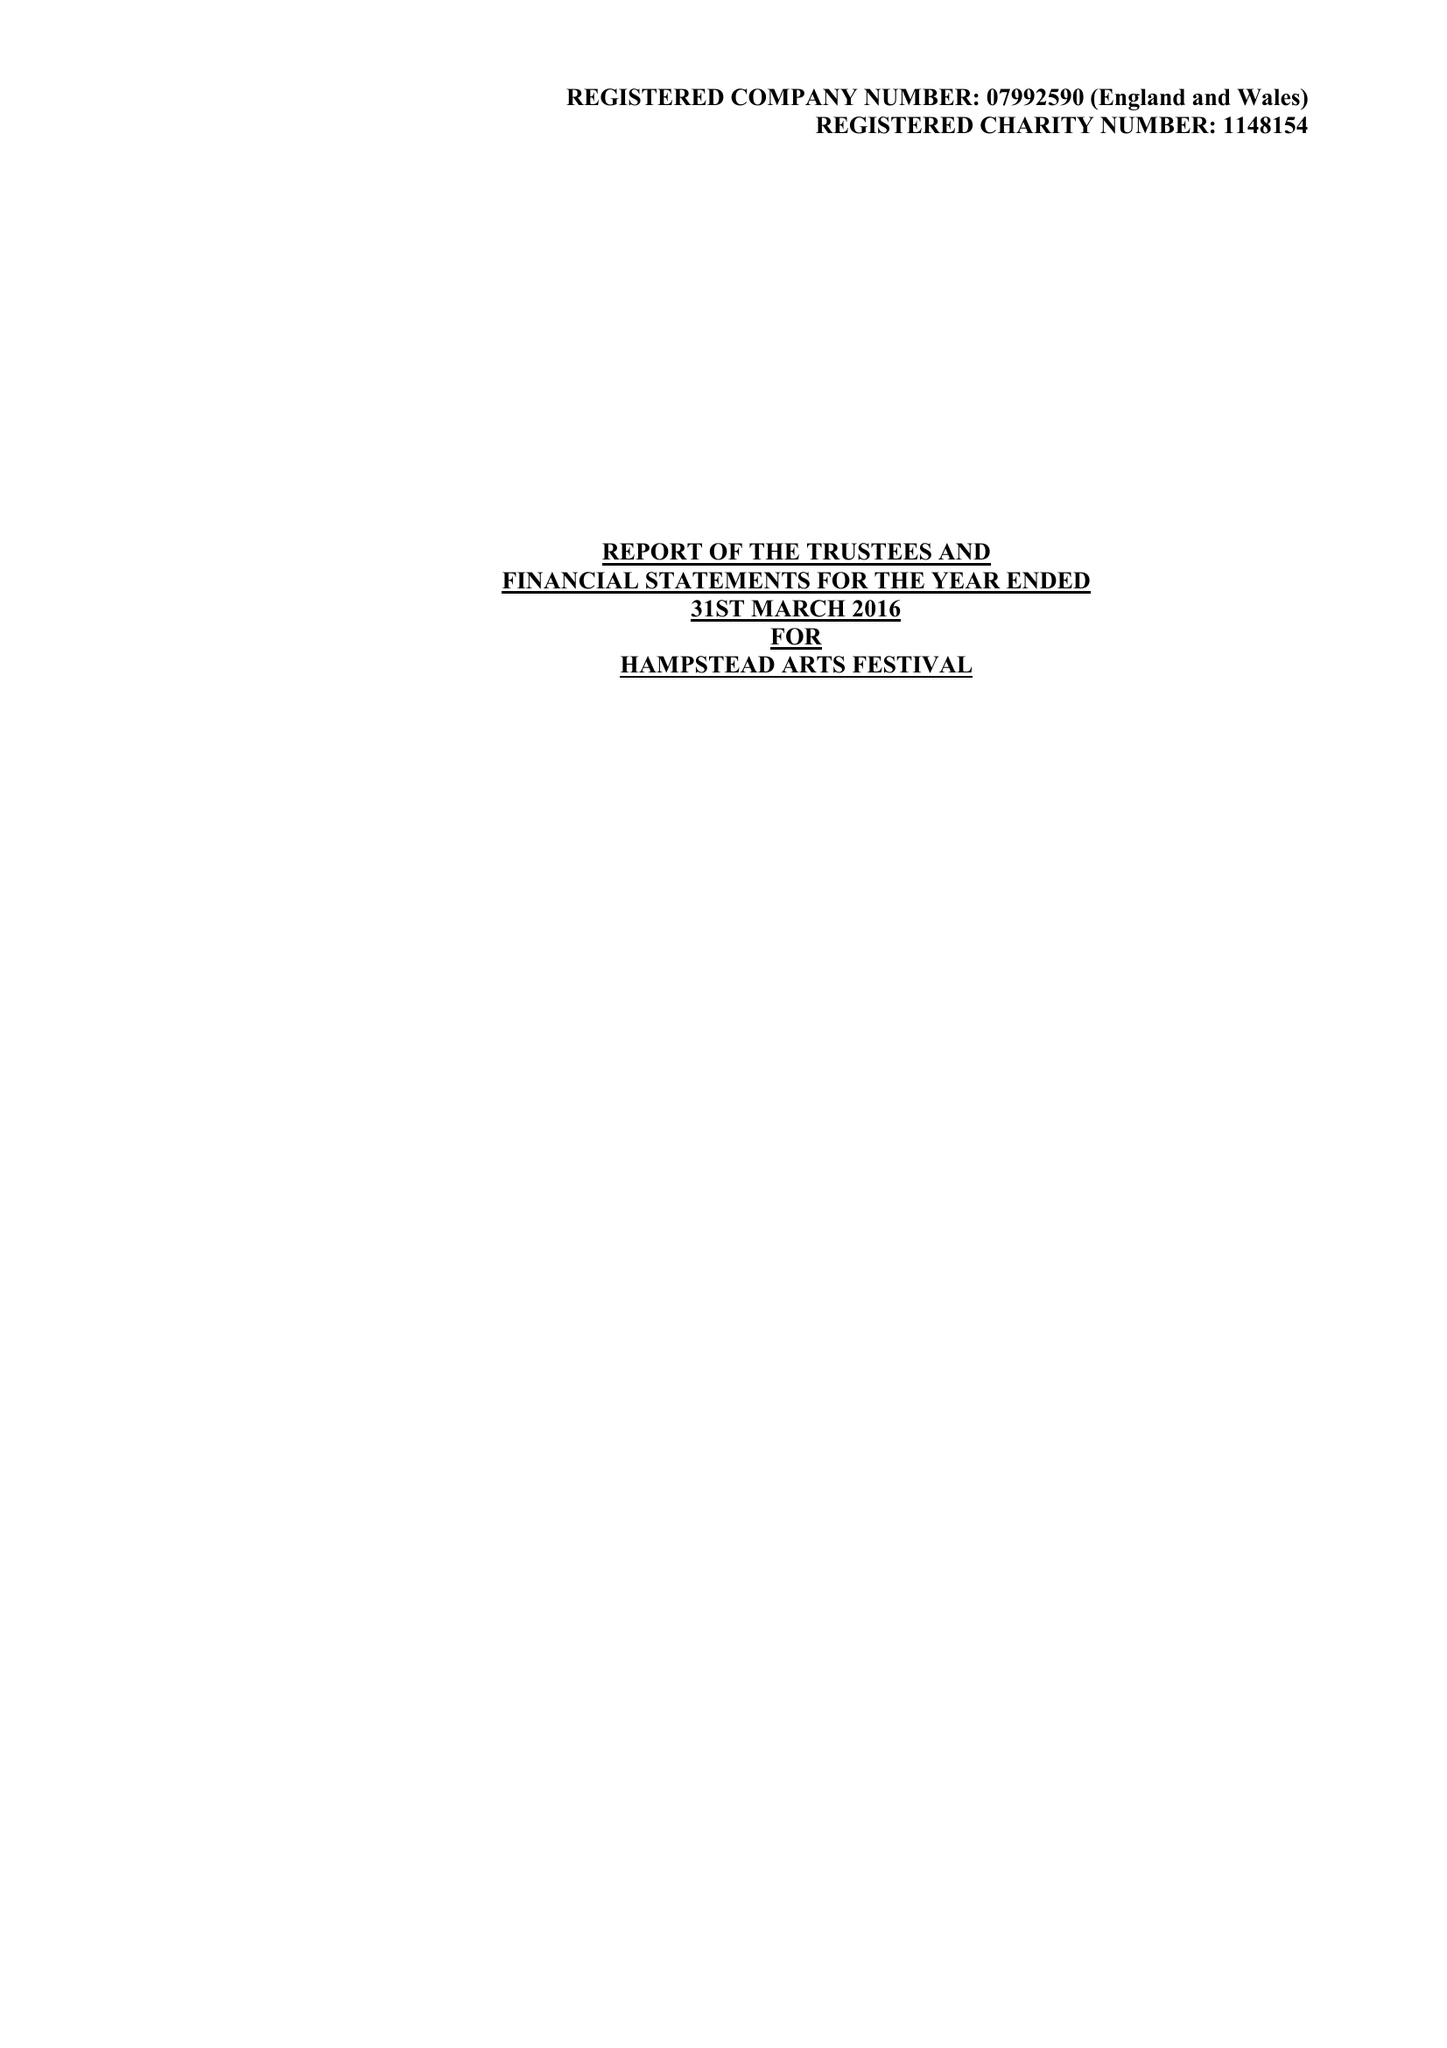What is the value for the charity_name?
Answer the question using a single word or phrase. Hampstead Arts Festival 